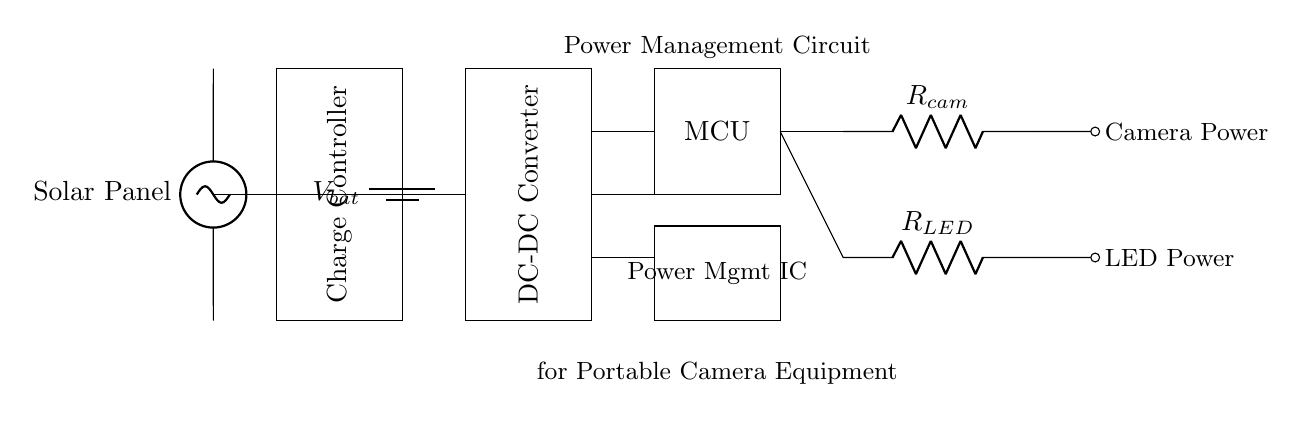What is the function of the DC-DC converter? The DC-DC converter adjusts the input voltage to the required output voltage level for the microcontroller and the peripherals.
Answer: Adjusts voltage What components receive power from the microcontroller? The camera and the LED are the components connected to the microcontroller, receiving power for operation.
Answer: Camera and LED What is the role of the charge controller? The charge controller regulates the voltage from the solar panel to charge the battery safely and efficiently.
Answer: Regulate charging How many different power outputs are illustrated? The circuit shows two distinct power outputs, one for the camera and another for the LED.
Answer: Two What kind of power source is indicated in the circuit? The circuit includes a battery and a solar panel as power sources, providing energy for the system.
Answer: Battery and solar panel What does 'R' signify in the context of the circuit diagram? The letter 'R' before the components represents resistors used to limit current to the camera and LED, preventing damage.
Answer: Resistors What is the purpose of the Power Management Integrated Circuit? The Power Management Integrated Circuit coordinates the distribution of power to various components, ensuring they function efficiently under varying conditions.
Answer: Manage power distribution 